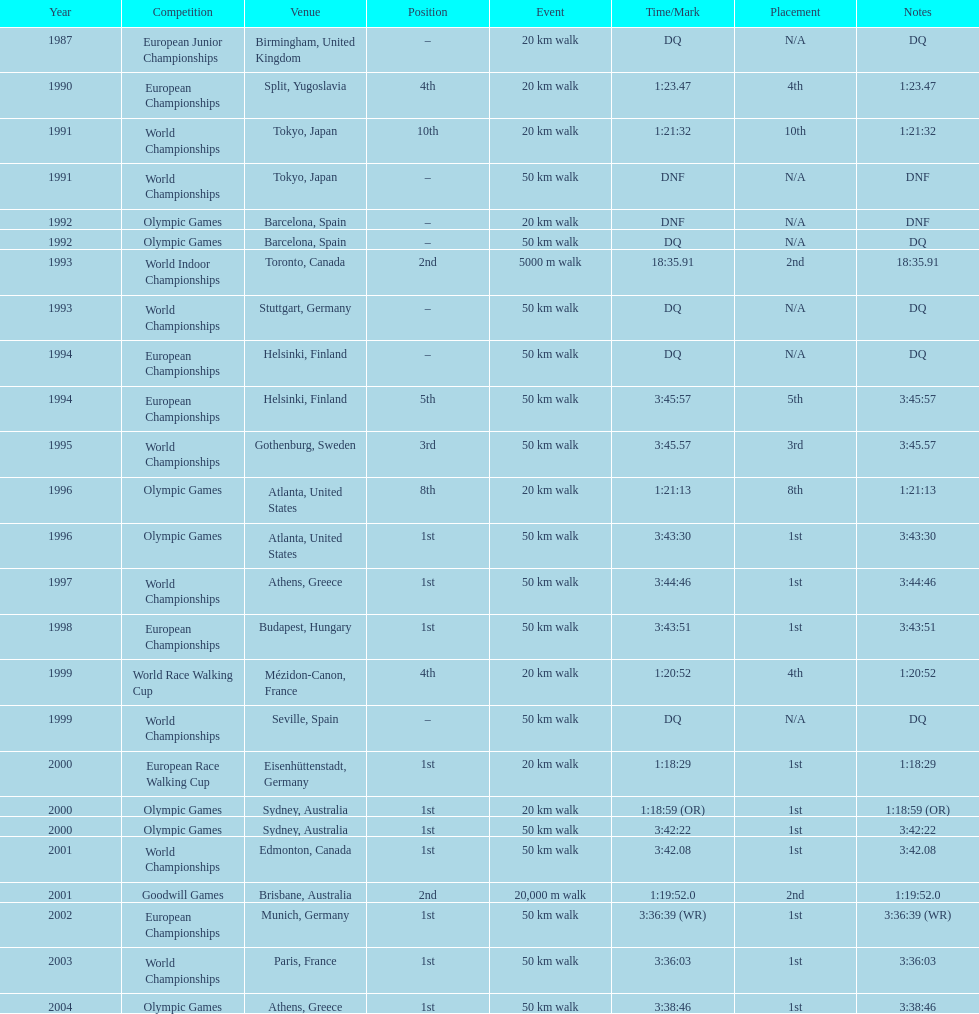How many times was korzeniowski disqualified from a competition? 5. 